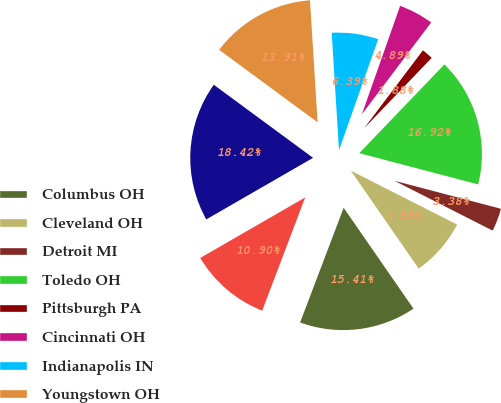Convert chart to OTSL. <chart><loc_0><loc_0><loc_500><loc_500><pie_chart><fcel>Columbus OH<fcel>Cleveland OH<fcel>Detroit MI<fcel>Toledo OH<fcel>Pittsburgh PA<fcel>Cincinnati OH<fcel>Indianapolis IN<fcel>Youngstown OH<fcel>Canton OH<fcel>Grand Rapids MI<nl><fcel>15.41%<fcel>7.89%<fcel>3.38%<fcel>16.92%<fcel>1.88%<fcel>4.89%<fcel>6.39%<fcel>13.91%<fcel>18.42%<fcel>10.9%<nl></chart> 